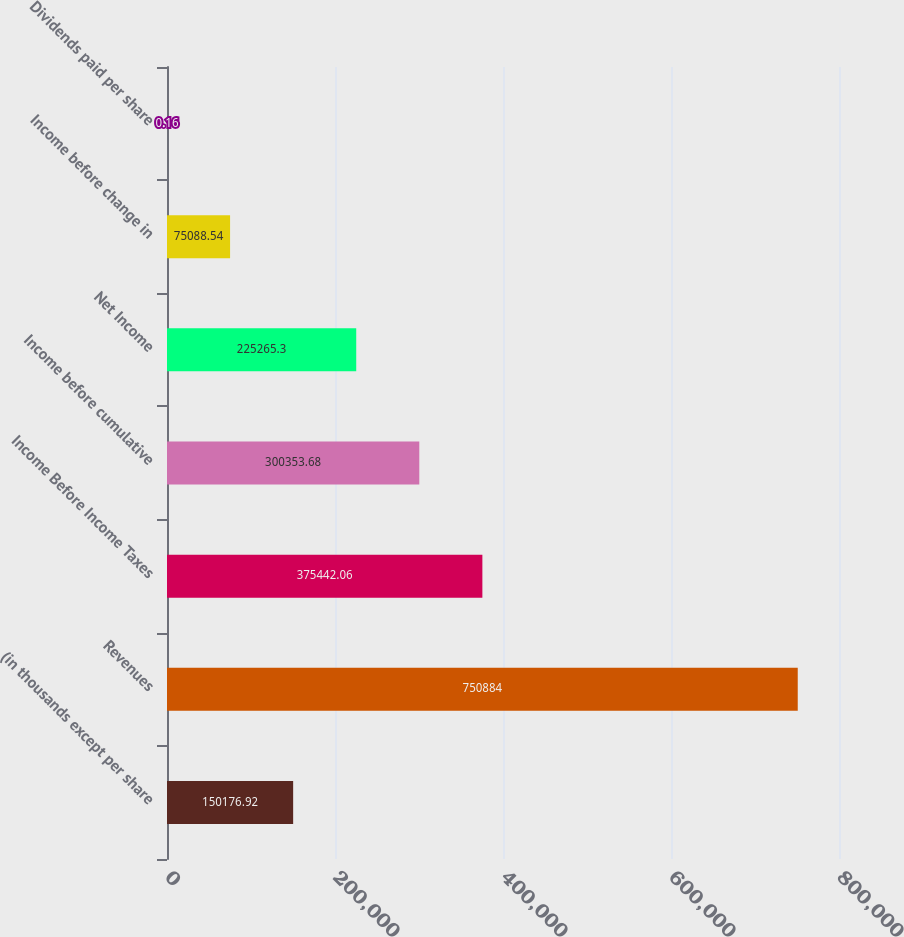Convert chart to OTSL. <chart><loc_0><loc_0><loc_500><loc_500><bar_chart><fcel>(in thousands except per share<fcel>Revenues<fcel>Income Before Income Taxes<fcel>Income before cumulative<fcel>Net Income<fcel>Income before change in<fcel>Dividends paid per share<nl><fcel>150177<fcel>750884<fcel>375442<fcel>300354<fcel>225265<fcel>75088.5<fcel>0.16<nl></chart> 